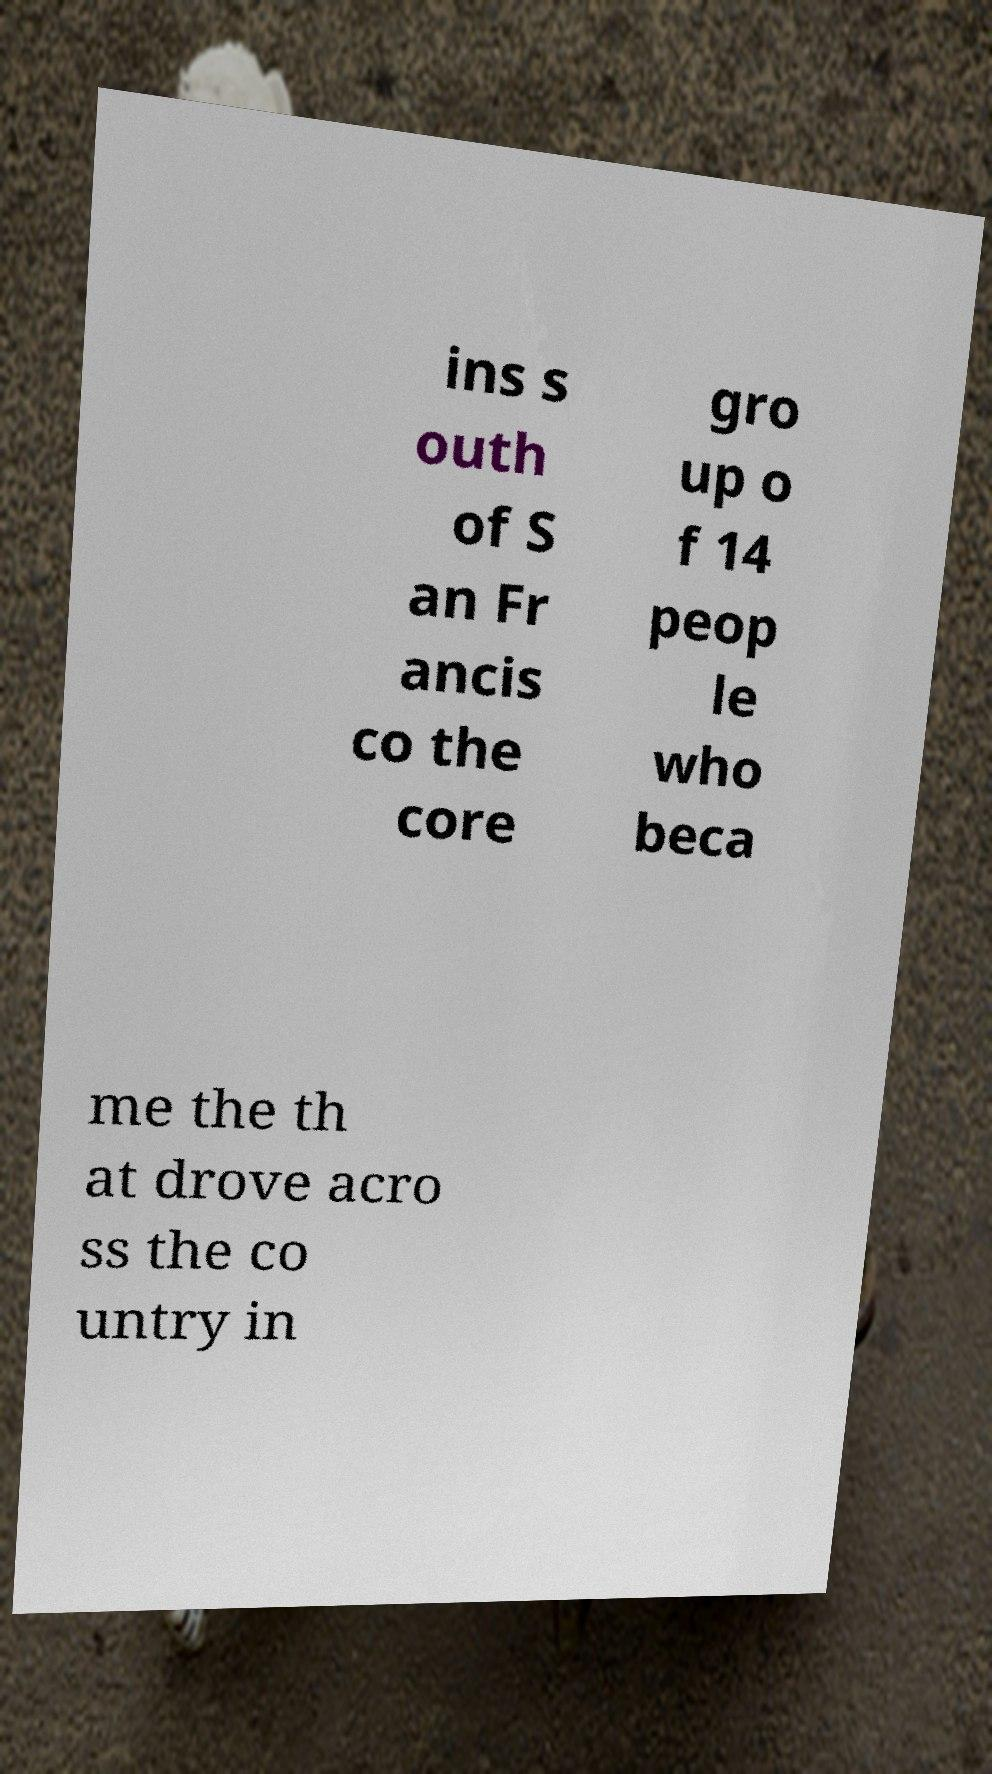I need the written content from this picture converted into text. Can you do that? ins s outh of S an Fr ancis co the core gro up o f 14 peop le who beca me the th at drove acro ss the co untry in 